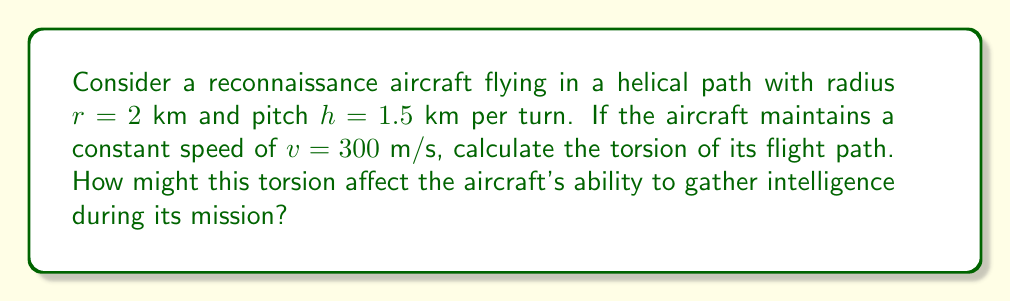Could you help me with this problem? To calculate the torsion of the helical flight path, we'll follow these steps:

1) The parametric equations for a helix are:
   $$x = r \cos(t)$$
   $$y = r \sin(t)$$
   $$z = \frac{h}{2\pi}t$$

2) We need to calculate the first, second, and third derivatives:
   $$\mathbf{r}'(t) = (-r\sin(t), r\cos(t), \frac{h}{2\pi})$$
   $$\mathbf{r}''(t) = (-r\cos(t), -r\sin(t), 0)$$
   $$\mathbf{r}'''(t) = (r\sin(t), -r\cos(t), 0)$$

3) The torsion $\tau$ is given by:
   $$\tau = \frac{(\mathbf{r}' \times \mathbf{r}'') \cdot \mathbf{r}'''}{|\mathbf{r}' \times \mathbf{r}''|^2}$$

4) Calculate $\mathbf{r}' \times \mathbf{r}''$:
   $$\mathbf{r}' \times \mathbf{r}'' = (r\frac{h}{2\pi}, r\frac{h}{2\pi}, r^2)$$

5) Calculate $(\mathbf{r}' \times \mathbf{r}'') \cdot \mathbf{r}'''$:
   $$(\mathbf{r}' \times \mathbf{r}'') \cdot \mathbf{r}''' = r^3\frac{h}{2\pi}$$

6) Calculate $|\mathbf{r}' \times \mathbf{r}''|^2$:
   $$|\mathbf{r}' \times \mathbf{r}''|^2 = r^2(\frac{h^2}{4\pi^2} + r^2)$$

7) Therefore, the torsion is:
   $$\tau = \frac{r^3\frac{h}{2\pi}}{r^2(\frac{h^2}{4\pi^2} + r^2)} = \frac{rh}{h^2 + 4\pi^2r^2}$$

8) Substitute the given values:
   $$\tau = \frac{2 \cdot 1.5}{1.5^2 + 4\pi^2 \cdot 2^2} \approx 0.0378 \text{ km}^{-1}$$

The torsion affects the aircraft's ability to gather intelligence by influencing the rate at which the aircraft's orientation changes along its flight path. A higher torsion means more rapid changes in orientation, which could impact sensor performance and data collection efficiency.
Answer: $0.0378 \text{ km}^{-1}$ 